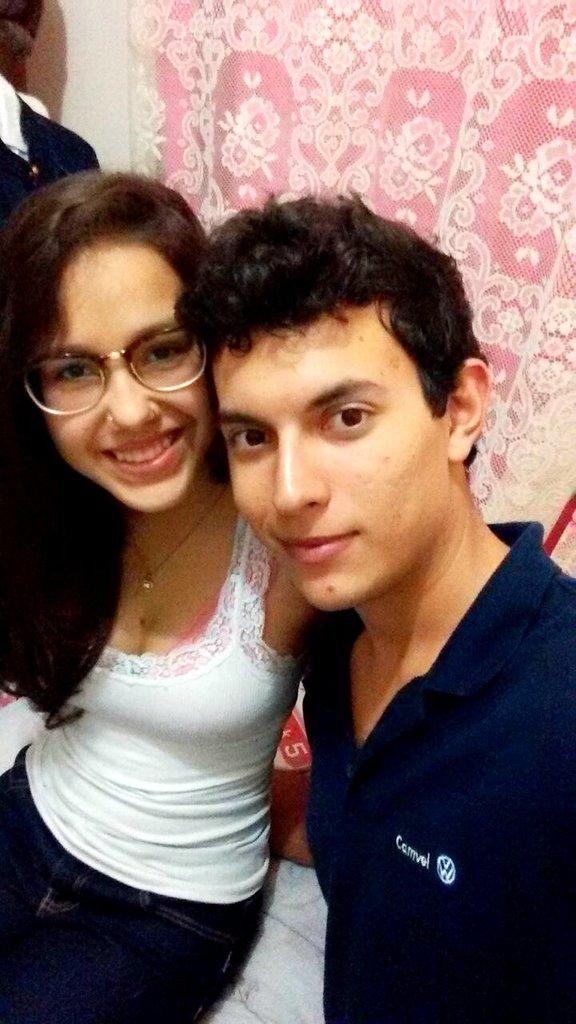How many people are present in the image? There are two persons in the image. What can be seen behind the persons? A curtain is visible behind the persons. What type of cherries are being served by the governor in the image? There is no governor or cherries present in the image. How many eggs are visible on the table in the image? There are no eggs visible in the image. 